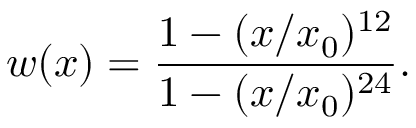Convert formula to latex. <formula><loc_0><loc_0><loc_500><loc_500>w ( x ) = \frac { 1 - ( x / x _ { 0 } ) ^ { 1 2 } } { 1 - ( x / x _ { 0 } ) ^ { 2 4 } } .</formula> 